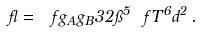Convert formula to latex. <formula><loc_0><loc_0><loc_500><loc_500>\gamma = \ f { g _ { A } g _ { B } } { 3 2 \pi ^ { 5 } } \ f { T ^ { 6 } } { \L d ^ { 2 } } \, .</formula> 